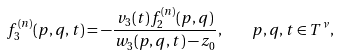Convert formula to latex. <formula><loc_0><loc_0><loc_500><loc_500>f _ { 3 } ^ { ( n ) } ( p , q , t ) = - \frac { v _ { 3 } ( t ) f _ { 2 } ^ { ( n ) } ( p , q ) } { w _ { 3 } ( p , q , t ) - z _ { 0 } } , \quad p , q , t \in { T } ^ { \nu } ,</formula> 